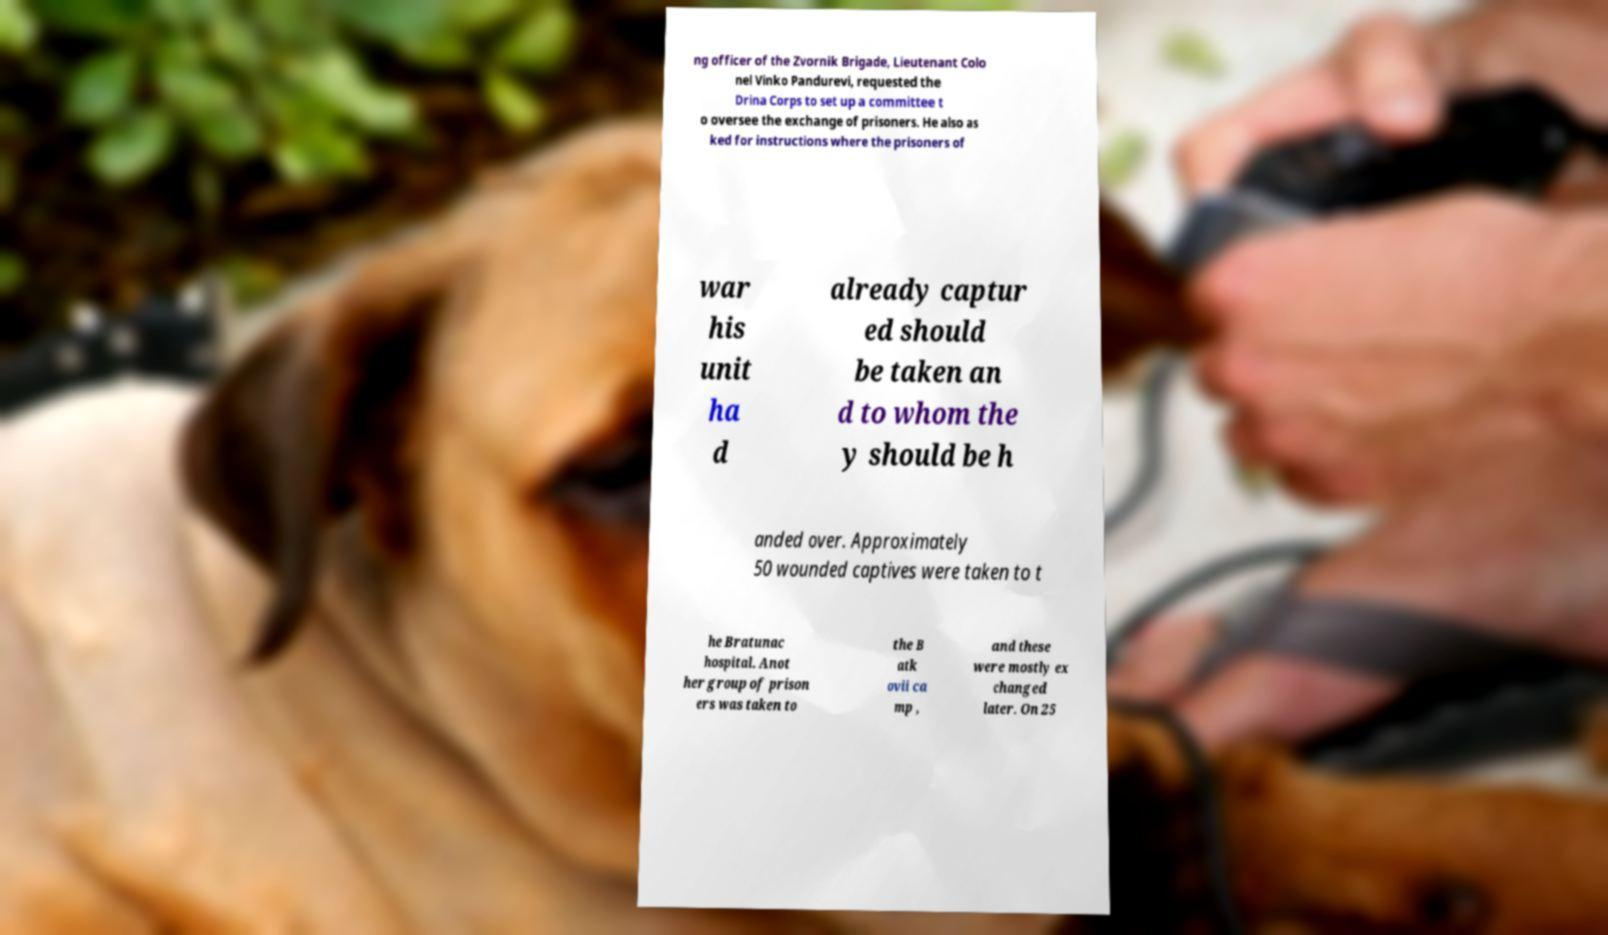There's text embedded in this image that I need extracted. Can you transcribe it verbatim? ng officer of the Zvornik Brigade, Lieutenant Colo nel Vinko Pandurevi, requested the Drina Corps to set up a committee t o oversee the exchange of prisoners. He also as ked for instructions where the prisoners of war his unit ha d already captur ed should be taken an d to whom the y should be h anded over. Approximately 50 wounded captives were taken to t he Bratunac hospital. Anot her group of prison ers was taken to the B atk ovii ca mp , and these were mostly ex changed later. On 25 